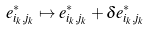Convert formula to latex. <formula><loc_0><loc_0><loc_500><loc_500>e _ { i _ { k } , j _ { k } } ^ { * } \mapsto e _ { i _ { k } , j _ { k } } ^ { * } + \delta e _ { i _ { k } , j _ { k } } ^ { * }</formula> 